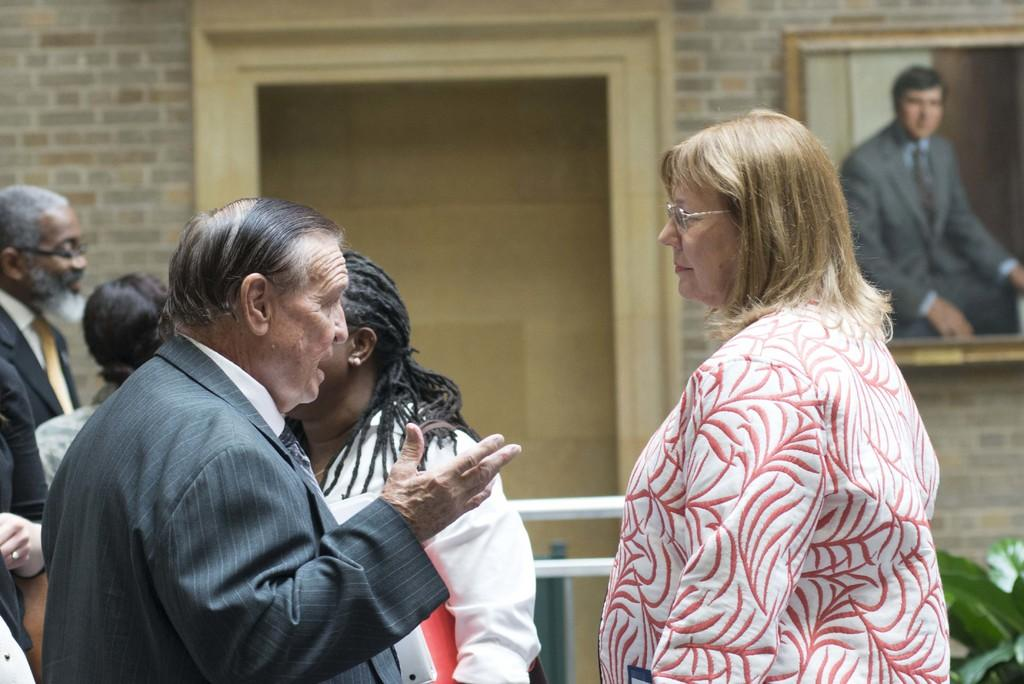How many people are in the image? There are persons standing in the image. What can be seen in the background of the image? There are iron rods, a wall, a window, and a photo frame attached to the wall in the background of the image. What type of notebook is the girl holding in the image? There is no girl or notebook present in the image. What shape is the photo frame in the image? The shape of the photo frame cannot be determined from the image, as it is not mentioned in the provided facts. 